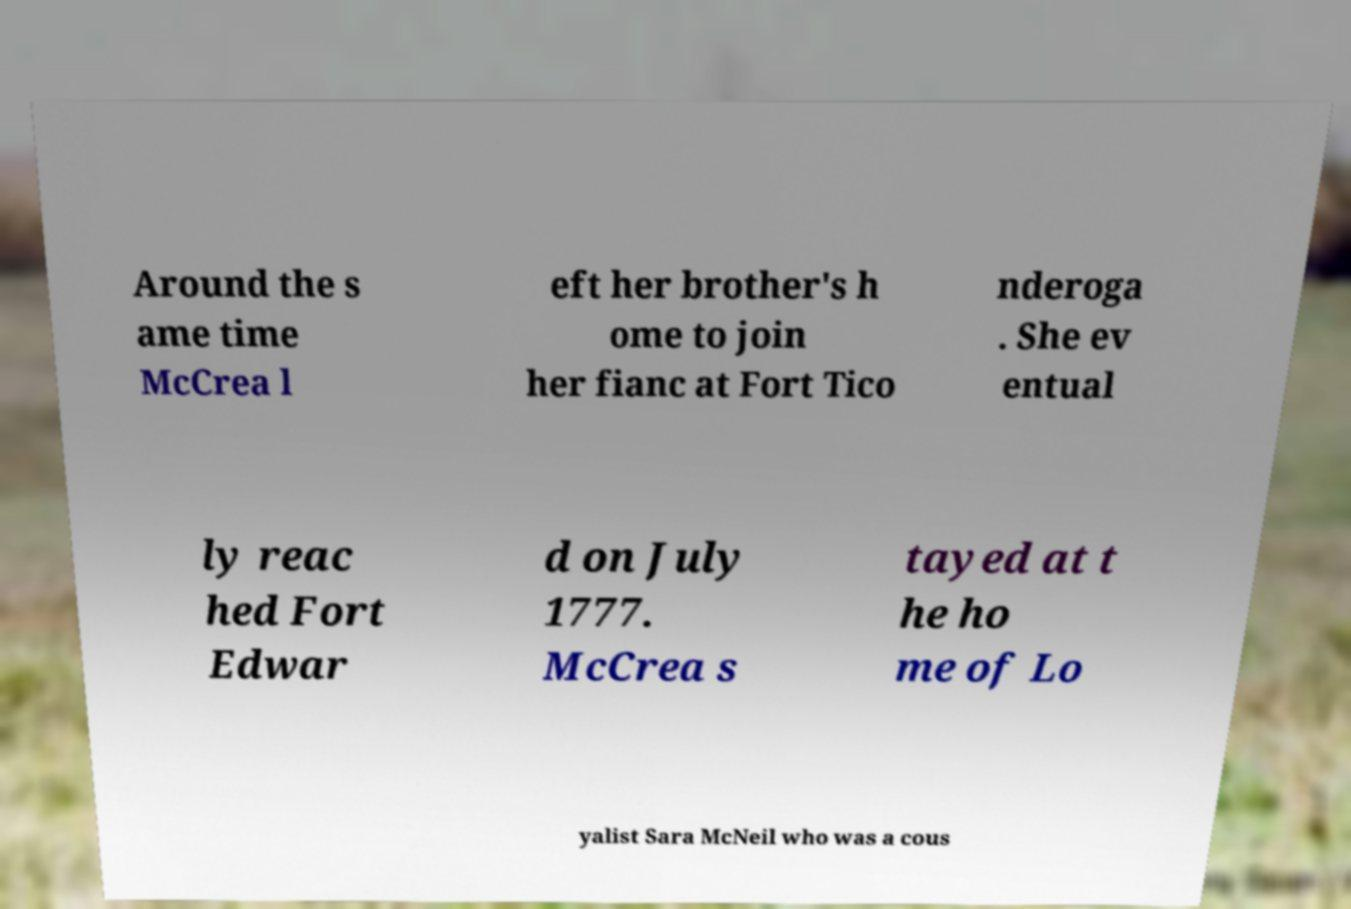There's text embedded in this image that I need extracted. Can you transcribe it verbatim? Around the s ame time McCrea l eft her brother's h ome to join her fianc at Fort Tico nderoga . She ev entual ly reac hed Fort Edwar d on July 1777. McCrea s tayed at t he ho me of Lo yalist Sara McNeil who was a cous 